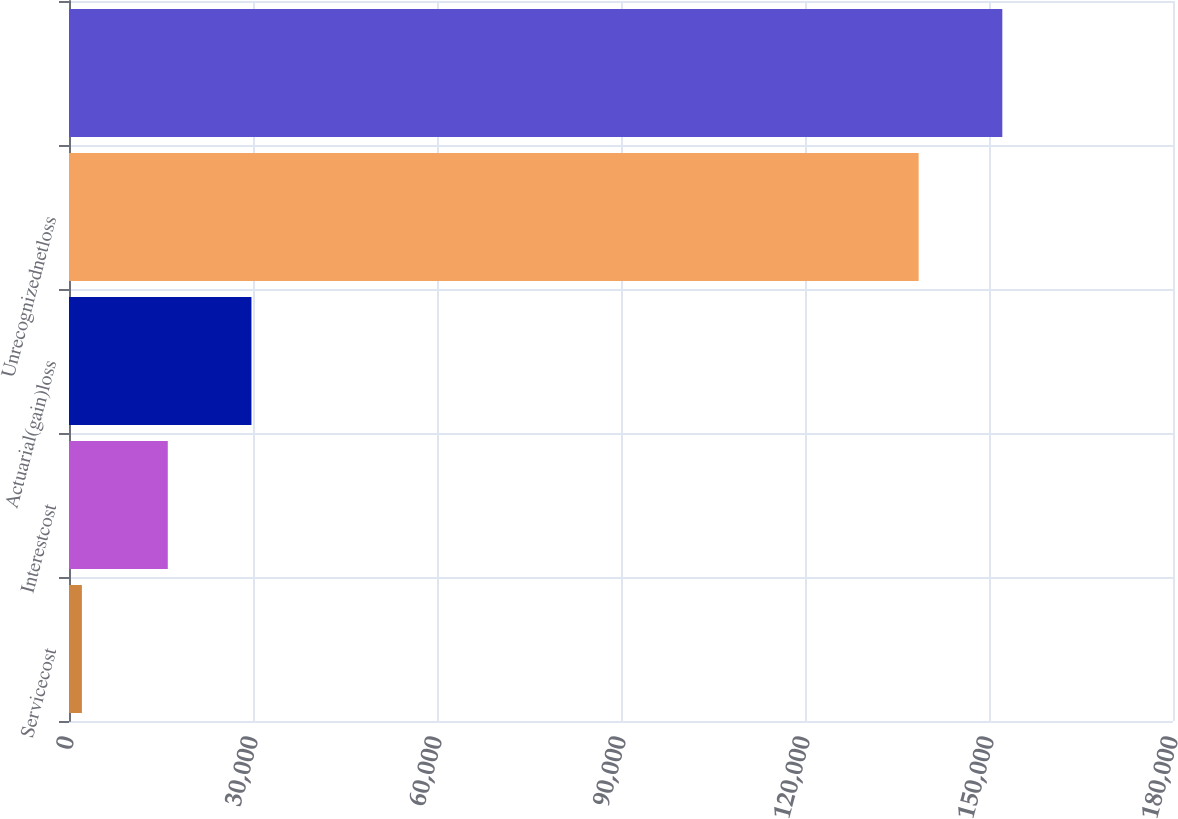<chart> <loc_0><loc_0><loc_500><loc_500><bar_chart><fcel>Servicecost<fcel>Interestcost<fcel>Actuarial(gain)loss<fcel>Unrecognizednetloss<fcel>Unnamed: 4<nl><fcel>2100<fcel>16106<fcel>29748.9<fcel>138529<fcel>152172<nl></chart> 